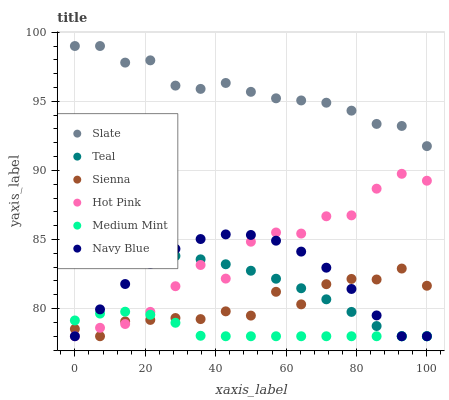Does Medium Mint have the minimum area under the curve?
Answer yes or no. Yes. Does Slate have the maximum area under the curve?
Answer yes or no. Yes. Does Navy Blue have the minimum area under the curve?
Answer yes or no. No. Does Navy Blue have the maximum area under the curve?
Answer yes or no. No. Is Teal the smoothest?
Answer yes or no. Yes. Is Hot Pink the roughest?
Answer yes or no. Yes. Is Navy Blue the smoothest?
Answer yes or no. No. Is Navy Blue the roughest?
Answer yes or no. No. Does Medium Mint have the lowest value?
Answer yes or no. Yes. Does Slate have the lowest value?
Answer yes or no. No. Does Slate have the highest value?
Answer yes or no. Yes. Does Navy Blue have the highest value?
Answer yes or no. No. Is Navy Blue less than Slate?
Answer yes or no. Yes. Is Slate greater than Medium Mint?
Answer yes or no. Yes. Does Navy Blue intersect Hot Pink?
Answer yes or no. Yes. Is Navy Blue less than Hot Pink?
Answer yes or no. No. Is Navy Blue greater than Hot Pink?
Answer yes or no. No. Does Navy Blue intersect Slate?
Answer yes or no. No. 